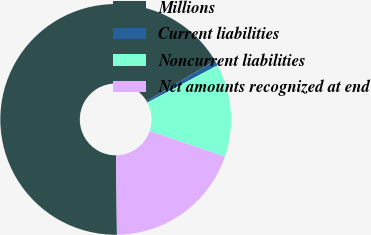Convert chart to OTSL. <chart><loc_0><loc_0><loc_500><loc_500><pie_chart><fcel>Millions<fcel>Current liabilities<fcel>Noncurrent liabilities<fcel>Net amounts recognized at end<nl><fcel>66.67%<fcel>0.73%<fcel>13.0%<fcel>19.6%<nl></chart> 